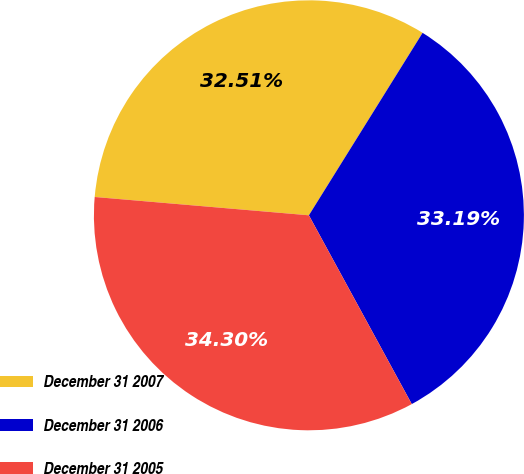Convert chart. <chart><loc_0><loc_0><loc_500><loc_500><pie_chart><fcel>December 31 2007<fcel>December 31 2006<fcel>December 31 2005<nl><fcel>32.51%<fcel>33.19%<fcel>34.3%<nl></chart> 